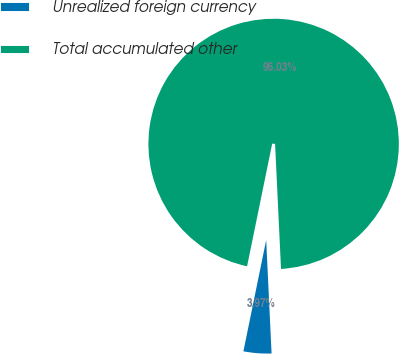Convert chart to OTSL. <chart><loc_0><loc_0><loc_500><loc_500><pie_chart><fcel>Unrealized foreign currency<fcel>Total accumulated other<nl><fcel>3.97%<fcel>96.03%<nl></chart> 